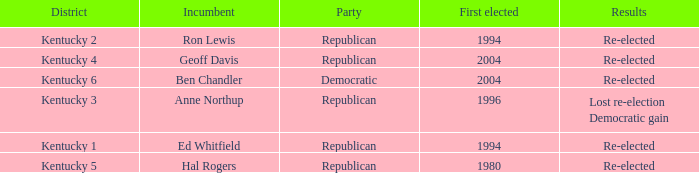In what year was the republican incumbent from Kentucky 2 district first elected? 1994.0. 